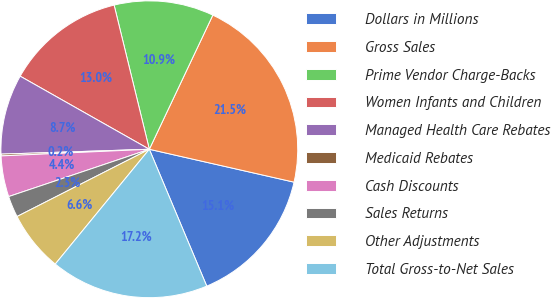Convert chart. <chart><loc_0><loc_0><loc_500><loc_500><pie_chart><fcel>Dollars in Millions<fcel>Gross Sales<fcel>Prime Vendor Charge-Backs<fcel>Women Infants and Children<fcel>Managed Health Care Rebates<fcel>Medicaid Rebates<fcel>Cash Discounts<fcel>Sales Returns<fcel>Other Adjustments<fcel>Total Gross-to-Net Sales<nl><fcel>15.12%<fcel>21.52%<fcel>10.85%<fcel>12.99%<fcel>8.72%<fcel>0.19%<fcel>4.45%<fcel>2.32%<fcel>6.59%<fcel>17.25%<nl></chart> 